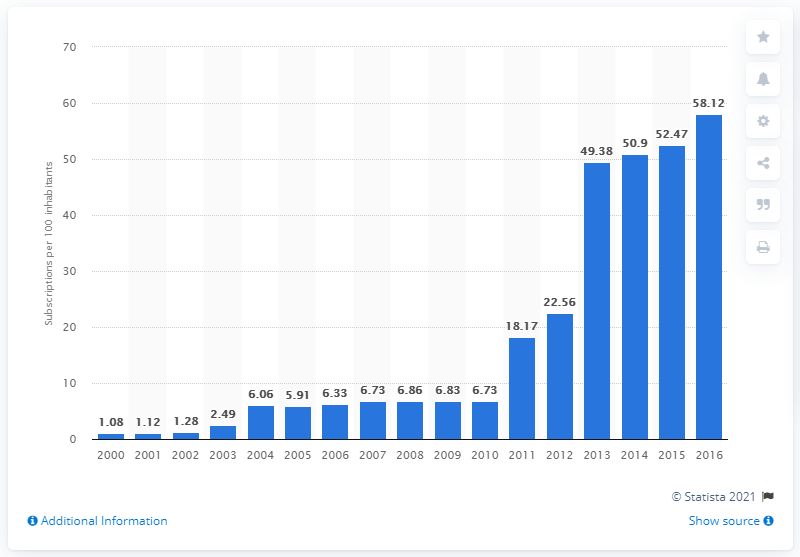Point out several critical features in this image. Between 2000 and 2016, the number of mobile cellular subscriptions registered for every 100 people in Somalia was 58.12. 